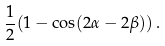Convert formula to latex. <formula><loc_0><loc_0><loc_500><loc_500>\frac { 1 } { 2 } ( 1 - \cos ( 2 \alpha - 2 \beta ) ) \, .</formula> 